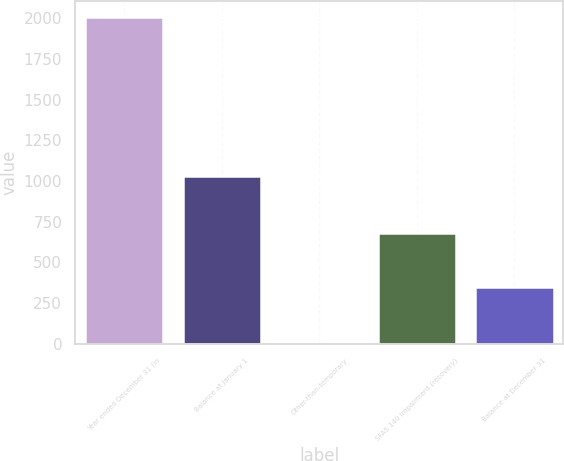Convert chart. <chart><loc_0><loc_0><loc_500><loc_500><bar_chart><fcel>Year ended December 31 (in<fcel>Balance at January 1<fcel>Other-than-temporary<fcel>SFAS 140 impairment (recovery)<fcel>Balance at December 31<nl><fcel>2005<fcel>1031<fcel>1<fcel>680<fcel>350<nl></chart> 